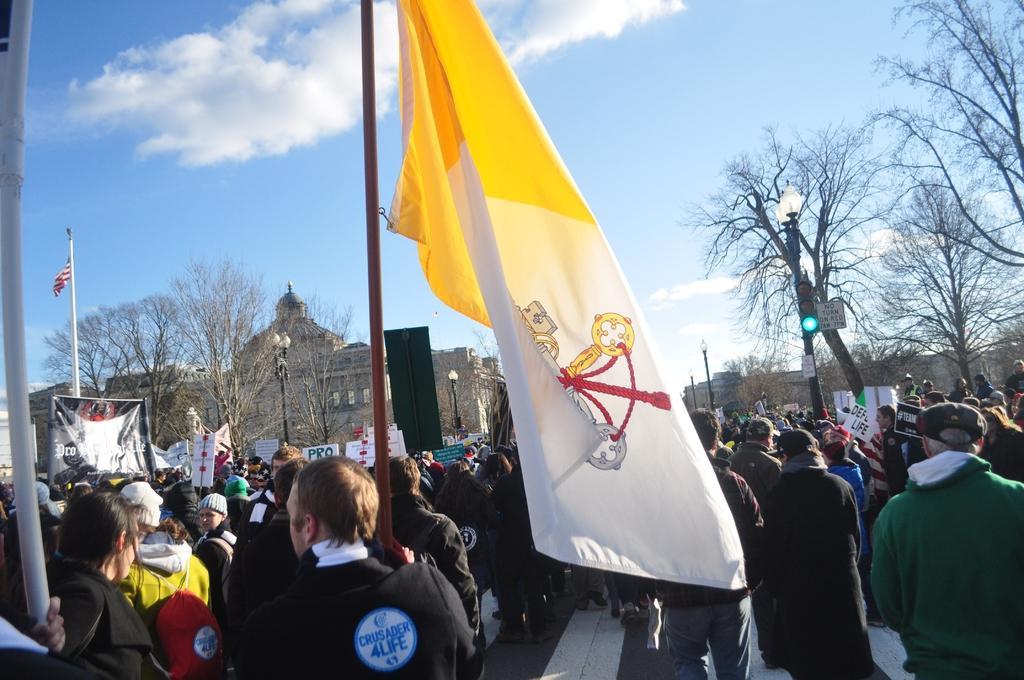Please provide a concise description of this image. This picture describes about group of people, they are standing on the road, in the middle of the image we can see a man, he is holding a flag, and few people are holding placards, in the background we can see few trees, traffic lights, poles and buildings. 